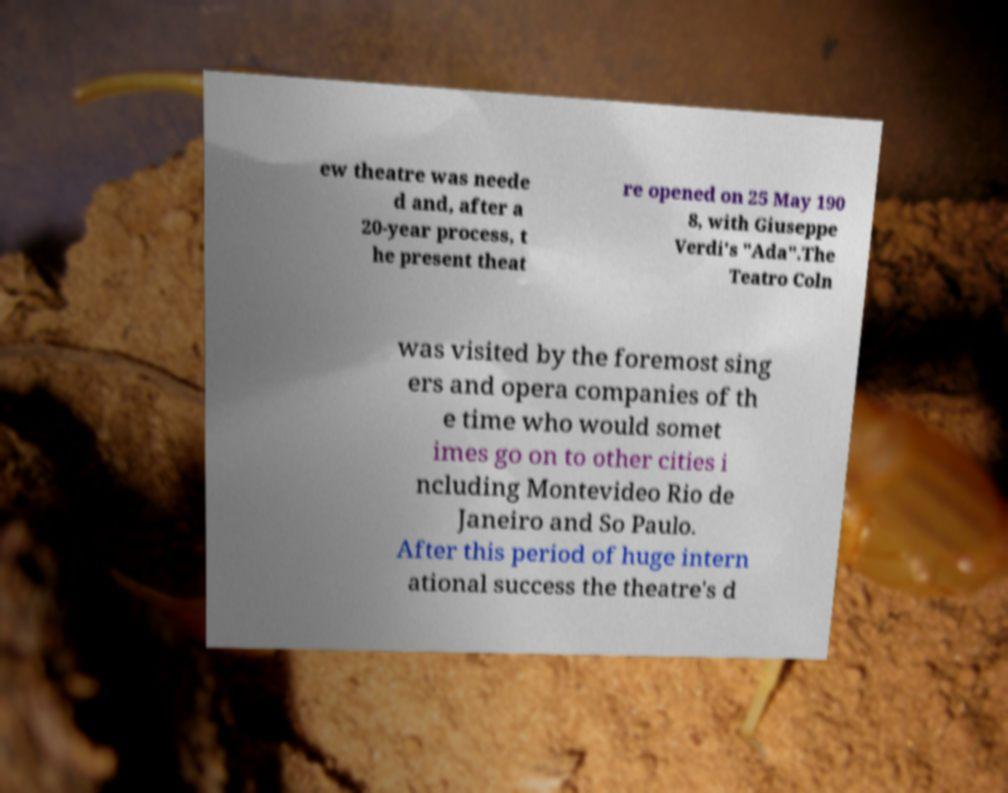Please identify and transcribe the text found in this image. ew theatre was neede d and, after a 20-year process, t he present theat re opened on 25 May 190 8, with Giuseppe Verdi's "Ada".The Teatro Coln was visited by the foremost sing ers and opera companies of th e time who would somet imes go on to other cities i ncluding Montevideo Rio de Janeiro and So Paulo. After this period of huge intern ational success the theatre's d 